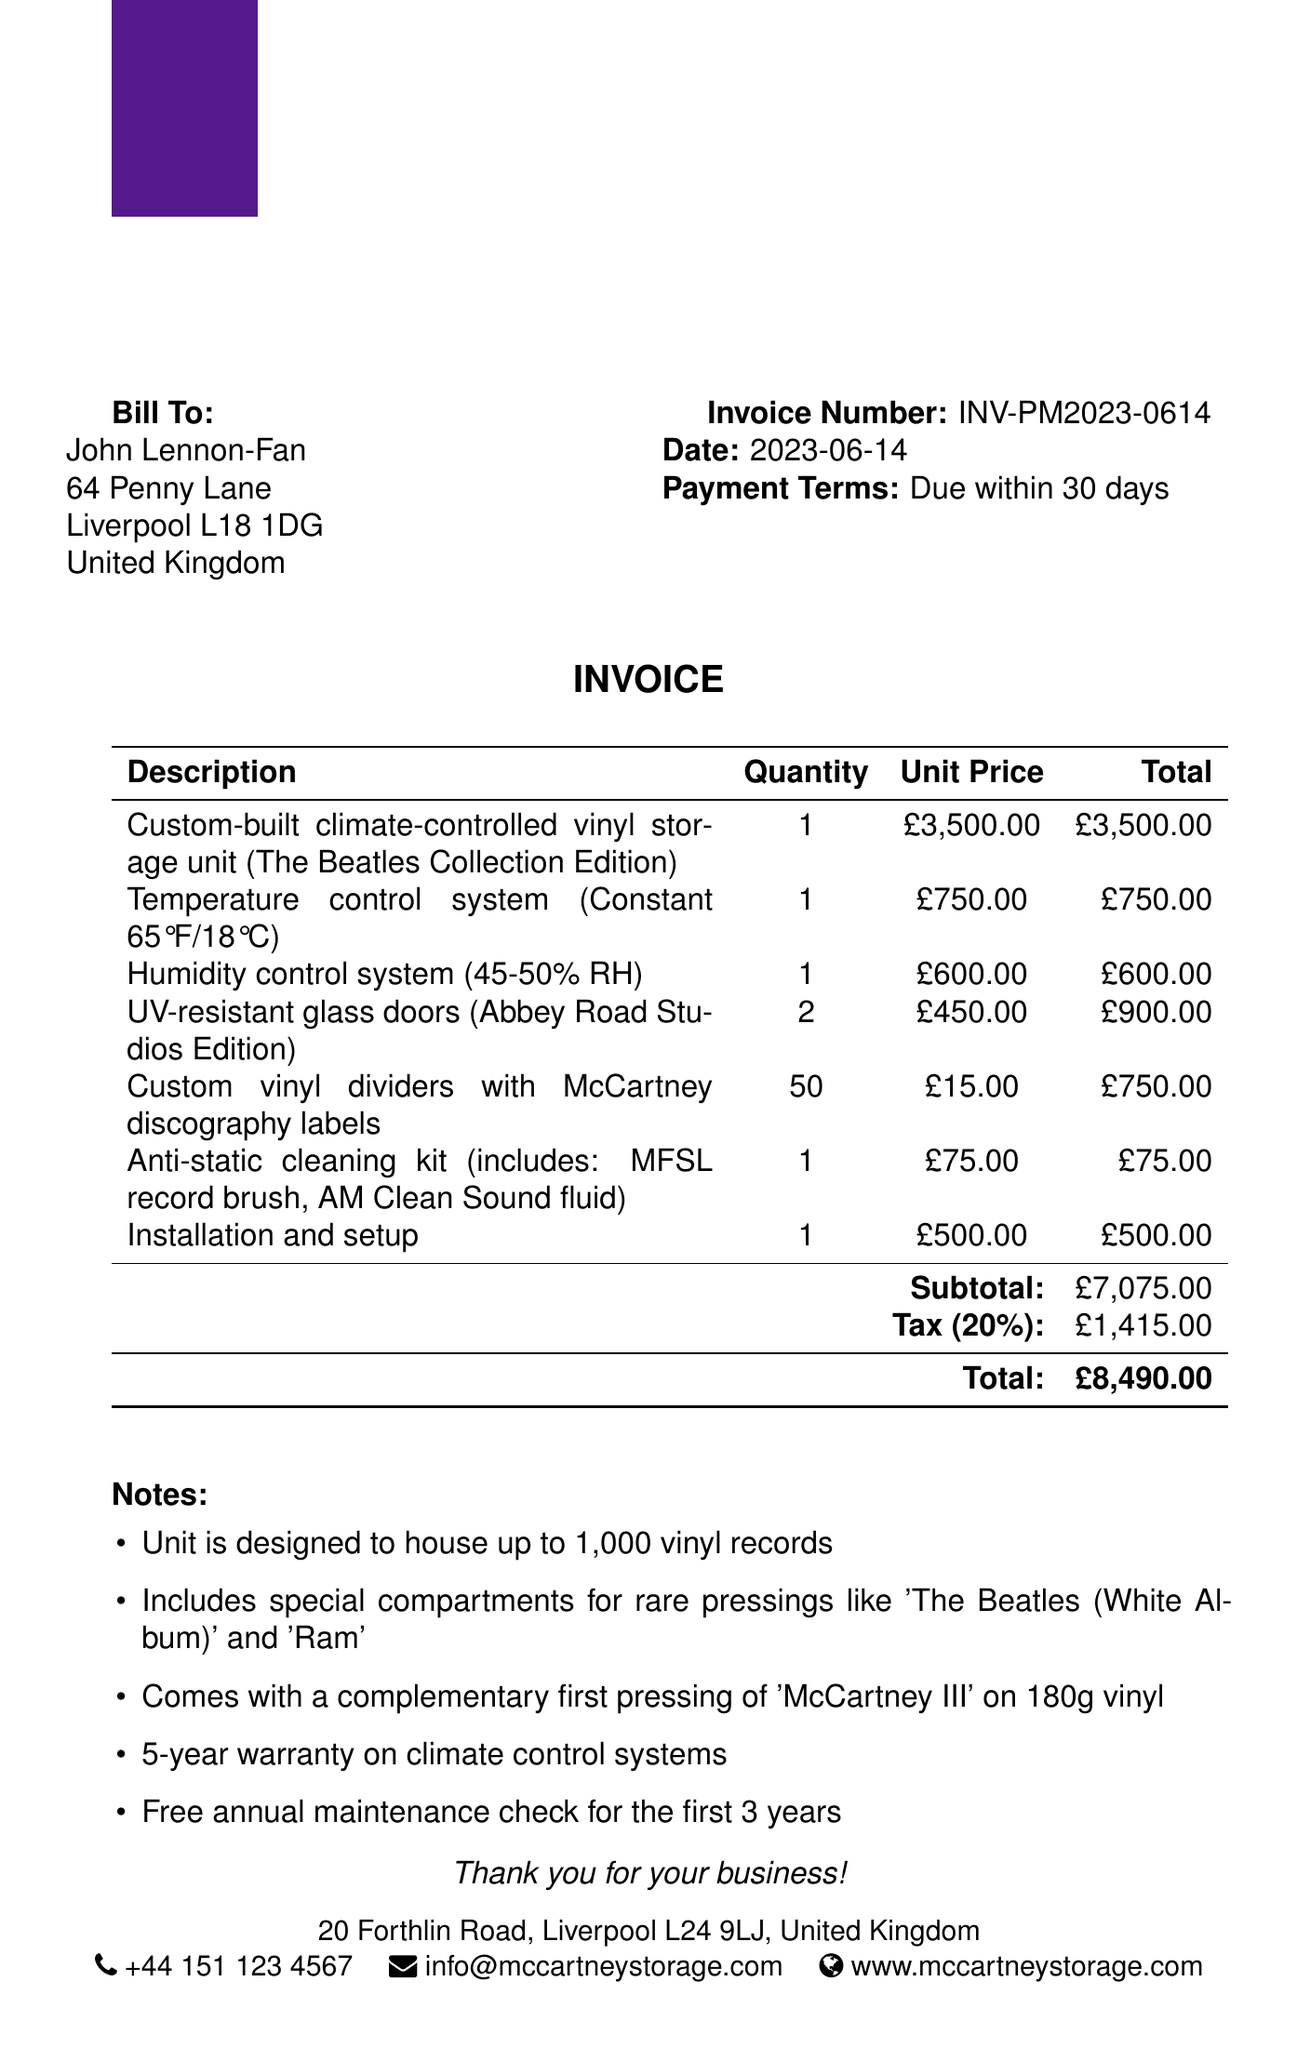What is the invoice number? The invoice number is specified at the top of the document, indicating the unique identifier for this invoice.
Answer: INV-PM2023-0614 What is the total amount due? The total amount is presented at the bottom of the invoice and represents the final sum owed by the customer.
Answer: £8,490.00 Who is the customer? The customer’s name appears prominently on the invoice as the individual or entity being billed for the services and products.
Answer: John Lennon-Fan What is the tax rate applied? The tax rate is mentioned in the invoice, detailing the percentage added to the subtotal for tax calculation.
Answer: 20% How many UV-resistant glass doors were ordered? The quantity of UV-resistant glass doors ordered is shown alongside the product description in the items list.
Answer: 2 What does the unit design accommodate? This information is found in the notes section, detailing the capacity and features of the vinyl storage unit.
Answer: 1,000 vinyl records What is included with the purchase? The invoice notes section lists promotional items or benefits included with the purchase, highlighting additional offerings.
Answer: First pressing of 'McCartney III' on 180g vinyl How long is the warranty on climate control systems? Warranty details appear in the notes section, providing information about the duration of coverage for specific components.
Answer: 5 years What payment terms are specified? Payment terms are clearly stated in the document to indicate when payment is expected to be made.
Answer: Due within 30 days 